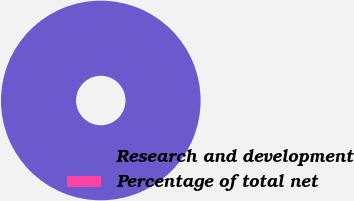<chart> <loc_0><loc_0><loc_500><loc_500><pie_chart><fcel>Research and development<fcel>Percentage of total net<nl><fcel>100.0%<fcel>0.0%<nl></chart> 